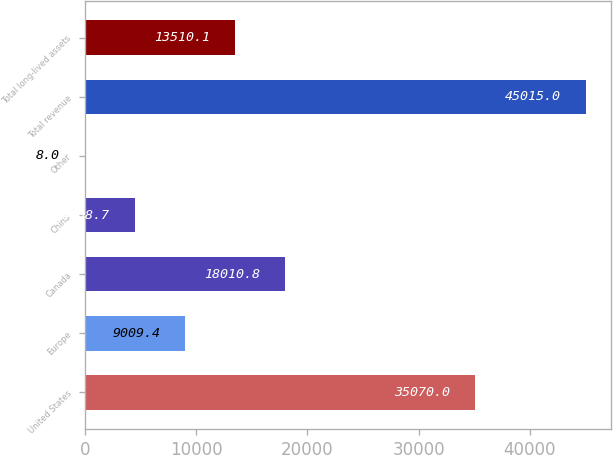Convert chart to OTSL. <chart><loc_0><loc_0><loc_500><loc_500><bar_chart><fcel>United States<fcel>Europe<fcel>Canada<fcel>China<fcel>Other<fcel>Total revenue<fcel>Total long-lived assets<nl><fcel>35070<fcel>9009.4<fcel>18010.8<fcel>4508.7<fcel>8<fcel>45015<fcel>13510.1<nl></chart> 